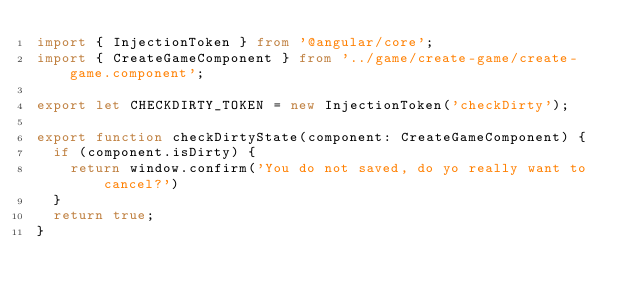<code> <loc_0><loc_0><loc_500><loc_500><_TypeScript_>import { InjectionToken } from '@angular/core';
import { CreateGameComponent } from '../game/create-game/create-game.component';

export let CHECKDIRTY_TOKEN = new InjectionToken('checkDirty');

export function checkDirtyState(component: CreateGameComponent) {
  if (component.isDirty) {
    return window.confirm('You do not saved, do yo really want to cancel?')
  }
  return true;
}
</code> 